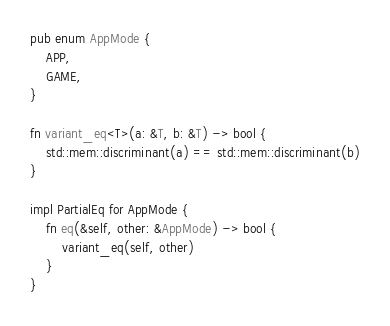Convert code to text. <code><loc_0><loc_0><loc_500><loc_500><_Rust_>pub enum AppMode {
    APP,
    GAME,
}

fn variant_eq<T>(a: &T, b: &T) -> bool {
    std::mem::discriminant(a) == std::mem::discriminant(b)
}

impl PartialEq for AppMode {
    fn eq(&self, other: &AppMode) -> bool {
        variant_eq(self, other)
    }
}
</code> 